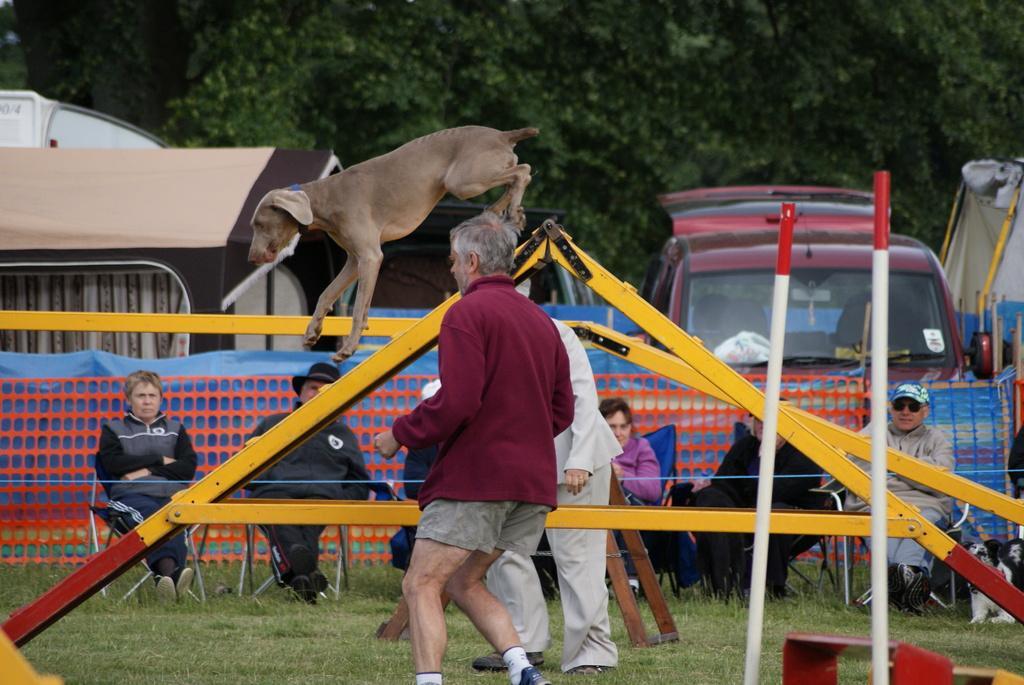Please provide a concise description of this image. In the center of the image, we can see an agility equipment set and there is a dog. In the background, there are people sitting on the chairs and we can see vehicles and some of the people are standing and in the front, we can see poles and there are trees. At the bottom, there is ground. 